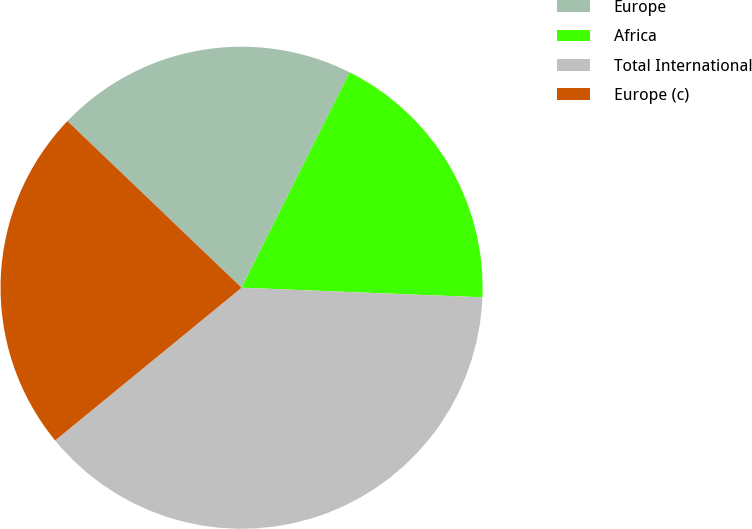Convert chart. <chart><loc_0><loc_0><loc_500><loc_500><pie_chart><fcel>Europe<fcel>Africa<fcel>Total International<fcel>Europe (c)<nl><fcel>20.25%<fcel>18.23%<fcel>38.44%<fcel>23.07%<nl></chart> 